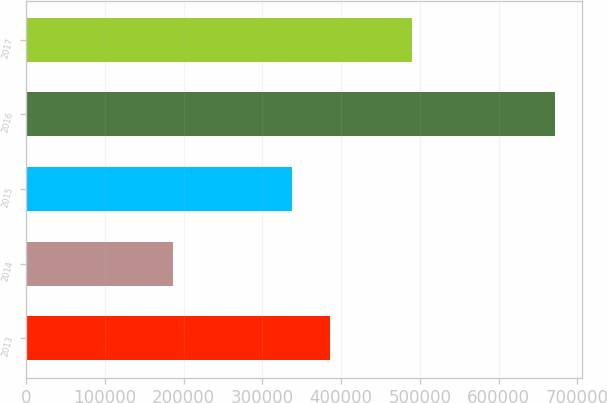<chart> <loc_0><loc_0><loc_500><loc_500><bar_chart><fcel>2013<fcel>2014<fcel>2015<fcel>2016<fcel>2017<nl><fcel>385494<fcel>187063<fcel>337019<fcel>671817<fcel>489317<nl></chart> 